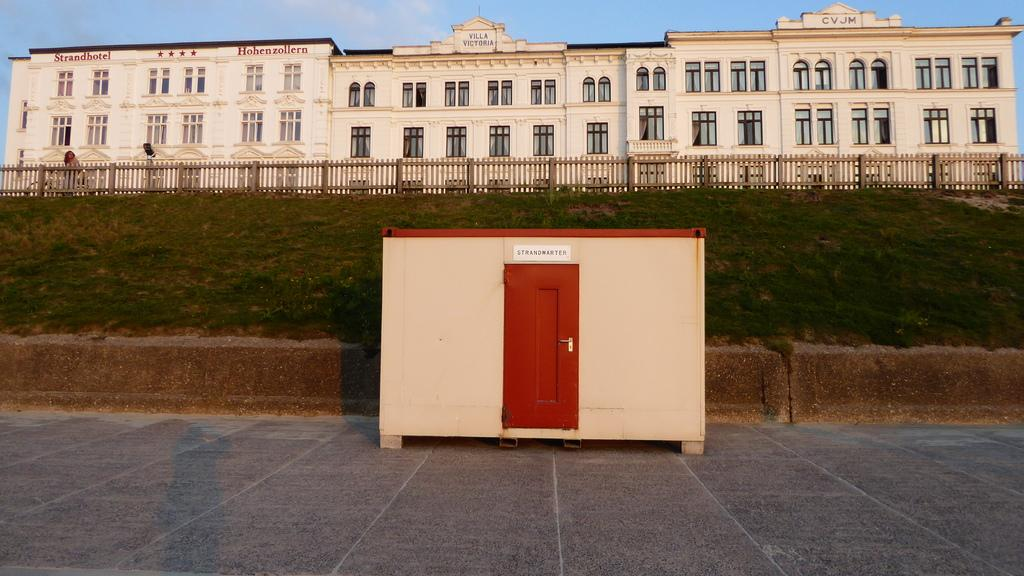What type of structure is in the image? There is a shelter in the image. What feature does the shelter have? The shelter has a door. What is behind the shelter? There is a wall behind the shelter. What type of vegetation is near the shelter? Grass is present near the shelter. What can be seen in the background of the image? There is a fence, at least one building, windows, and the sky visible in the background of the image. What type of answer can be seen in the image? There is no answer present in the image; it is a picture of a shelter with a door, a wall, grass, a fence, a building, windows, and the sky visible in the background. 